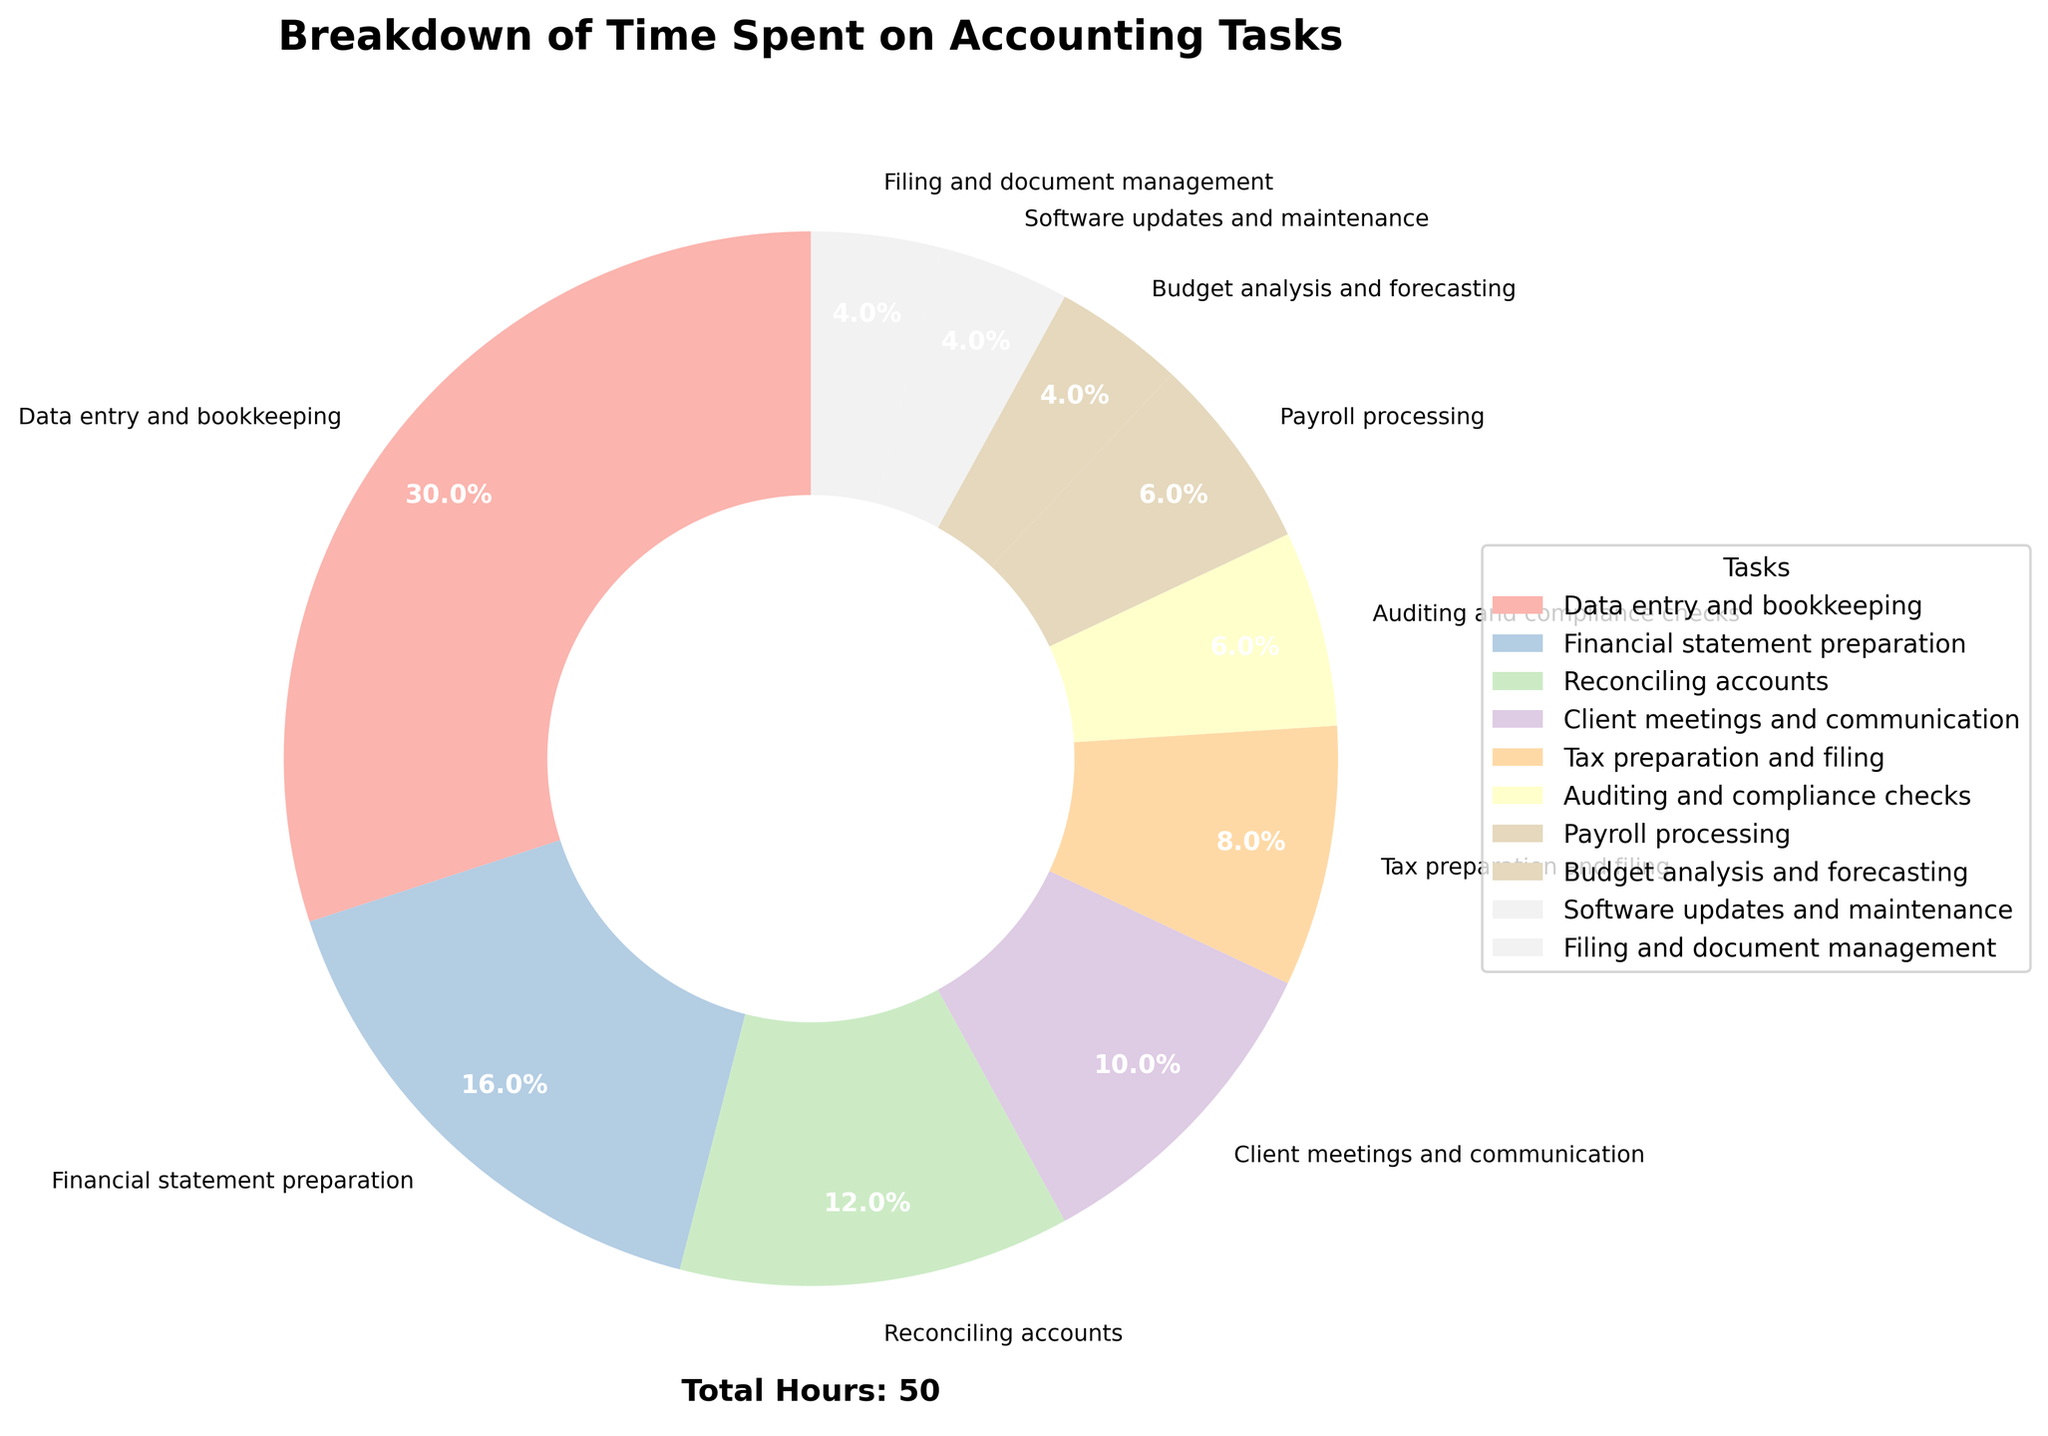What percentage of the total time is spent on data entry and bookkeeping? According to the pie chart, data entry and bookkeeping take up 15 hours per week. The percentages shown on the chart indicate that this segment covers 32.6% of the total time.
Answer: 32.6% Which task has the least amount of time spent on it, and what is that time? By examining the pie chart, we see that software updates and maintenance, budget analysis and forecasting, and filing and document management each have the smallest segments, indicating 2 hours each.
Answer: Software updates and maintenance, budget analysis and forecasting, filing and document management all have 2 hours What is the difference in hours between data entry and bookkeeping and tax preparation and filing? Data entry and bookkeeping take 15 hours, while tax preparation and filing take 4 hours. The difference is 15 - 4 = 11 hours.
Answer: 11 hours How does the time spent on client meetings and communication compare to reconciling accounts? Client meetings and communication take up 5 hours, as indicated by the chart. Reconciling accounts take 6 hours. Therefore, reconciliation has 1 more hour spent on it compared to client meetings.
Answer: 1 hour more for reconciliations What fraction of the total time is spent on financial statement preparation out of the total hours displayed in the chart? Financial statement preparation is 8 hours. The total hours spent is 50 hours as noted (sum of all tasks). Therefore, the fraction is 8/50 = 4/25.
Answer: 4/25 What two tasks combined take up the same amount of time as data entry and bookkeeping? From the chart, reconciling accounts (6 hours) and financial statement preparation (8 hours) combined are 6 + 8 = 14 hours. Adding another task such as auditing and compliance checks (3 hours) would bring it close but not exact. Therefore, a correct pair could be payroll processing (3 hours) and financial statements preparation (8 hours). Together 3 + 8 = 11 which will not match. So after checking, it seems no exact two tasks can sum up to 15 hours.
Answer: No such exact pair Which task is represented by the widest wedge in the pie chart? The pie chart shows data entry and bookkeeping as having the widest wedge, covering 15 hours which is the largest value presented, representing 32.6% of total time.
Answer: Data entry and bookkeeping How many hours are collectively spent on auditing and compliance checks and payroll processing? The pie chart indicates that auditing and compliance checks take 3 hours and payroll processing takes another 3 hours. Therefore, collectively they take 3 + 3 = 6 hours.
Answer: 6 hours 